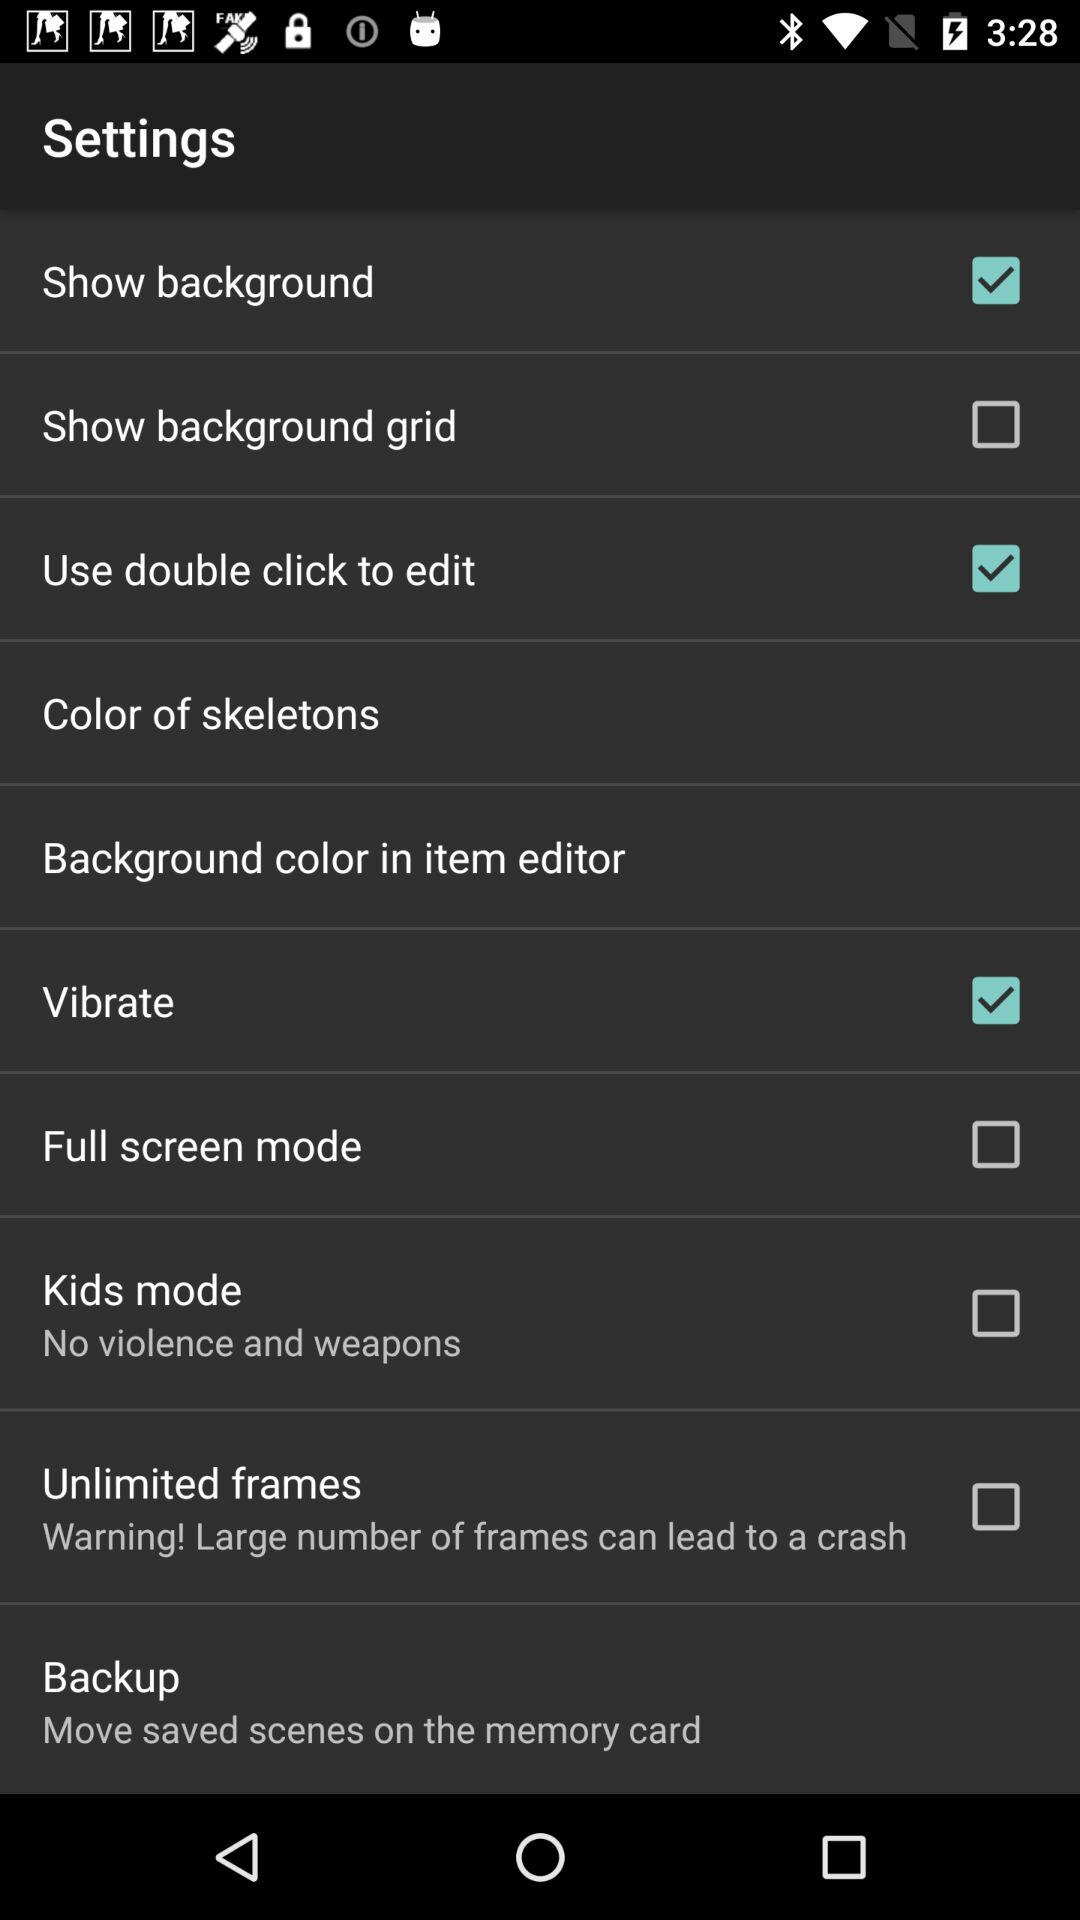Where can we save backups? We can save backups to the memory card. 